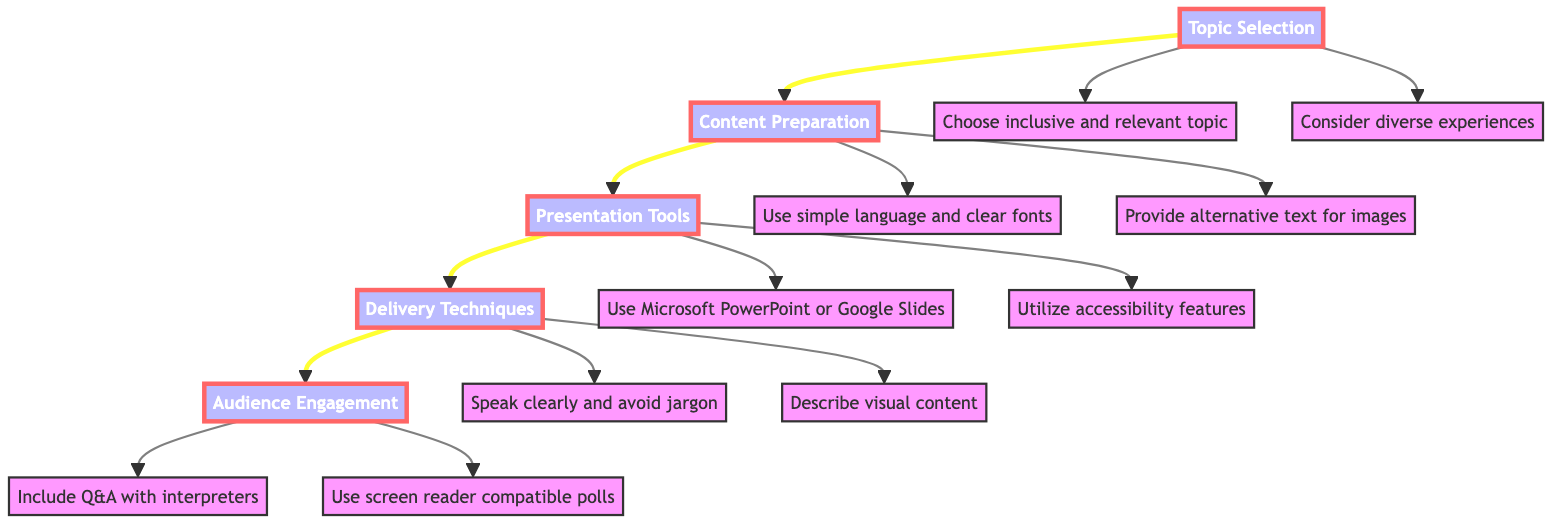What is the first stage in the flow chart? The first stage is "Topic Selection," which is the starting point for the process depicted in the flow chart.
Answer: Topic Selection How many main stages are present in the flow chart? The flow chart contains five main stages: Topic Selection, Content Preparation, Presentation Tools, Delivery Techniques, and Audience Engagement.
Answer: 5 What stage comes immediately after Content Preparation? The stage that follows Content Preparation is "Presentation Tools," which focuses on selecting tools that support accessibility.
Answer: Presentation Tools What is one of the criteria mentioned for topic selection? One of the criteria is "relevance," which focuses on selecting research areas that explore diverse experiences of individuals with disabilities.
Answer: Relevance What technique is suggested for effective delivery in the Delivery Techniques stage? The technique suggested is "verbal clarity," which emphasizes speaking at a moderate pace and avoiding jargon for better understanding.
Answer: Verbal clarity Which tool is mentioned for creating accessible presentations? "Microsoft PowerPoint" is mentioned as a tool that supports accessibility features such as closed captions and accessible templates.
Answer: Microsoft PowerPoint What type of engagement activities are recommended in the Audience Engagement stage? The recommended activities include "Q&A sessions with sign language interpreters" and "real-time polls with screen reader compatibility."
Answer: Q&A sessions with sign language interpreters Which aspect of content preparation focuses on multimedia? The aspect focusing on multimedia is providing "alternative text for images and transcripts for videos," ensuring all content is accessible.
Answer: Multimedia content What are the two key elements that should be included in visual aids during delivery? The key elements are "description of visual content for individuals with visual impairments" and "verbal clarity" during presentations.
Answer: Description of visual content and verbal clarity 